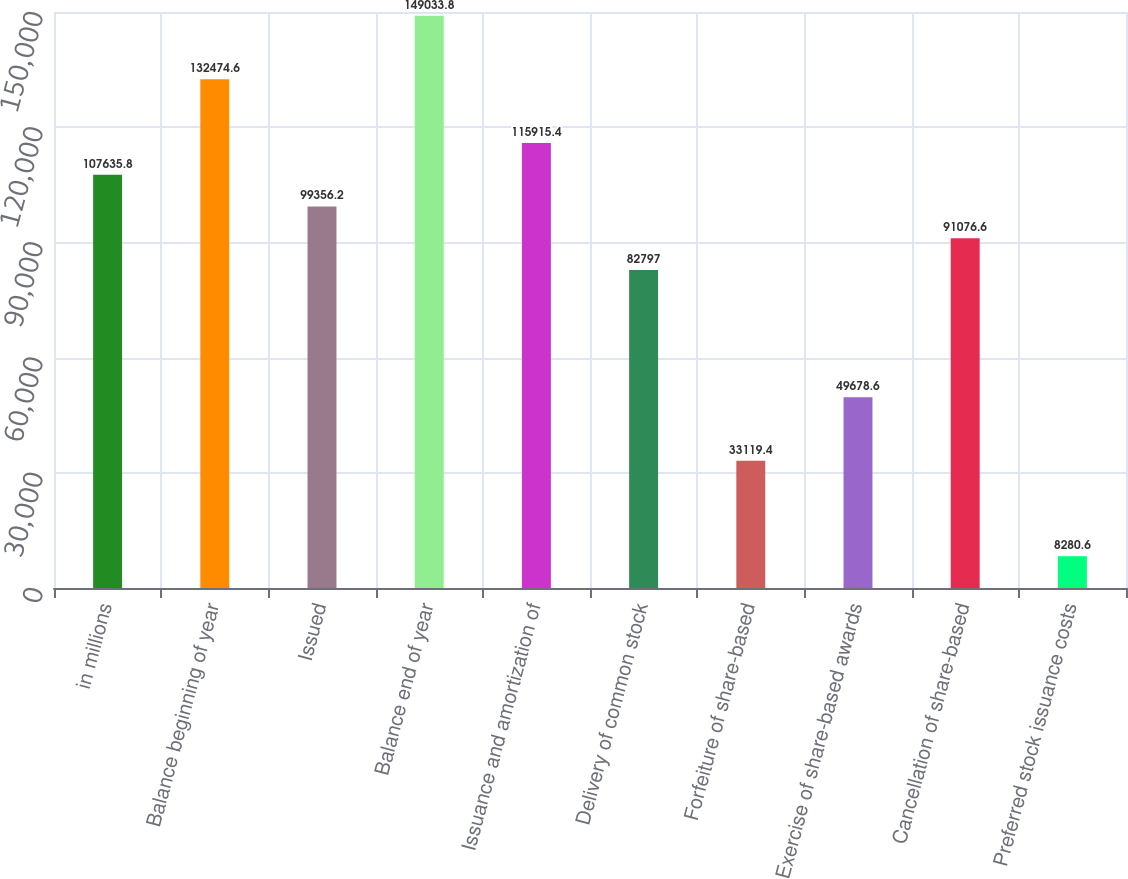Convert chart. <chart><loc_0><loc_0><loc_500><loc_500><bar_chart><fcel>in millions<fcel>Balance beginning of year<fcel>Issued<fcel>Balance end of year<fcel>Issuance and amortization of<fcel>Delivery of common stock<fcel>Forfeiture of share-based<fcel>Exercise of share-based awards<fcel>Cancellation of share-based<fcel>Preferred stock issuance costs<nl><fcel>107636<fcel>132475<fcel>99356.2<fcel>149034<fcel>115915<fcel>82797<fcel>33119.4<fcel>49678.6<fcel>91076.6<fcel>8280.6<nl></chart> 